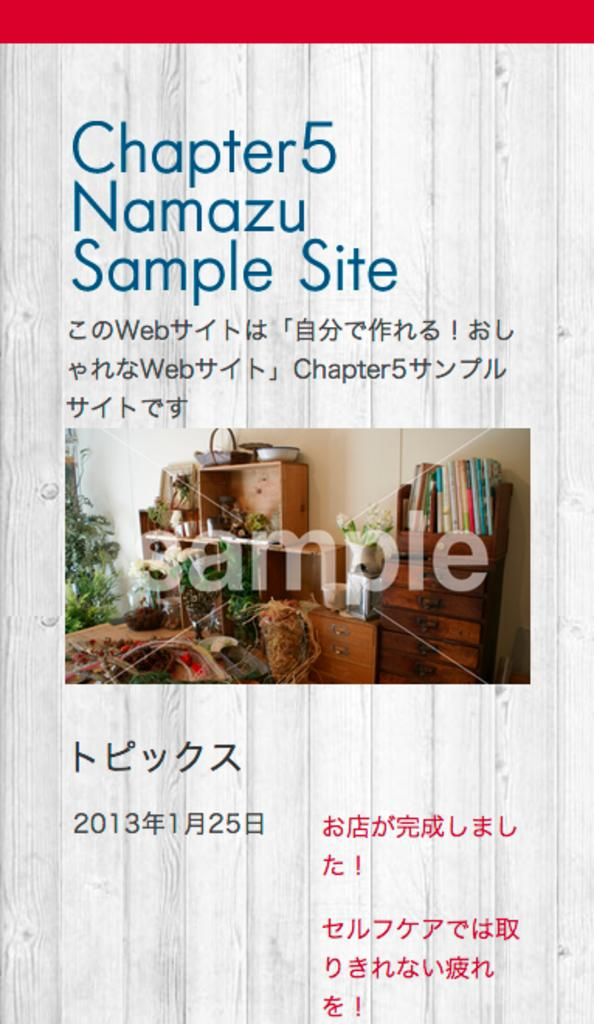<image>
Provide a brief description of the given image. A poster details Chapter 5 of Namazu and a sample site. 